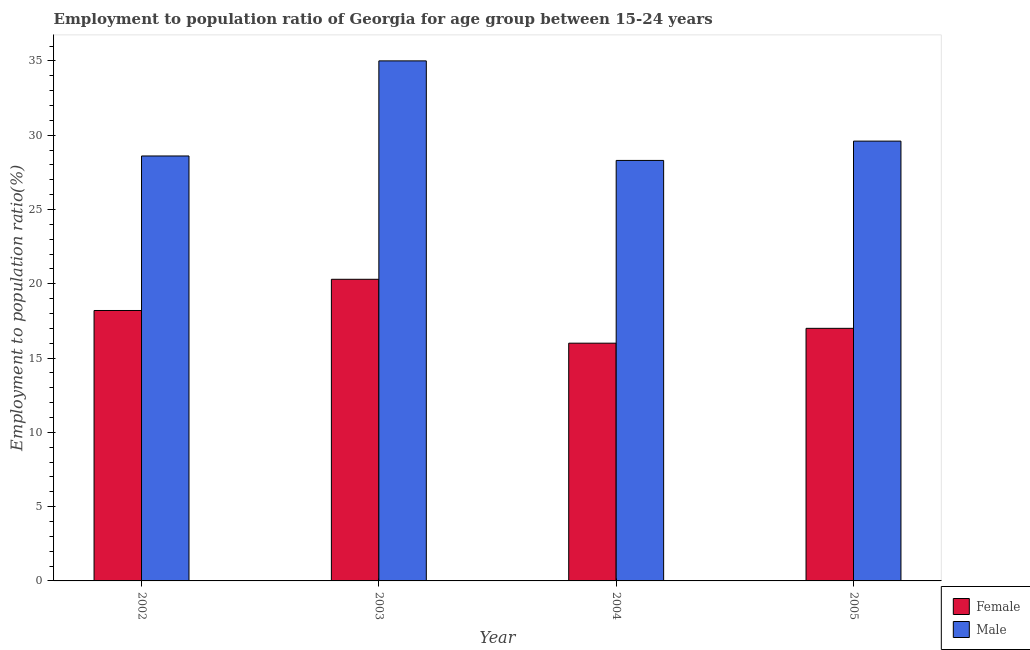How many groups of bars are there?
Provide a succinct answer. 4. Are the number of bars on each tick of the X-axis equal?
Offer a terse response. Yes. How many bars are there on the 4th tick from the right?
Your answer should be very brief. 2. What is the employment to population ratio(female) in 2004?
Keep it short and to the point. 16. Across all years, what is the maximum employment to population ratio(female)?
Give a very brief answer. 20.3. Across all years, what is the minimum employment to population ratio(male)?
Provide a succinct answer. 28.3. In which year was the employment to population ratio(male) minimum?
Provide a succinct answer. 2004. What is the total employment to population ratio(male) in the graph?
Provide a short and direct response. 121.5. What is the difference between the employment to population ratio(female) in 2002 and that in 2003?
Give a very brief answer. -2.1. What is the difference between the employment to population ratio(female) in 2005 and the employment to population ratio(male) in 2003?
Your response must be concise. -3.3. What is the average employment to population ratio(female) per year?
Provide a short and direct response. 17.88. In how many years, is the employment to population ratio(female) greater than 5 %?
Offer a terse response. 4. What is the ratio of the employment to population ratio(male) in 2004 to that in 2005?
Provide a short and direct response. 0.96. Is the employment to population ratio(male) in 2003 less than that in 2004?
Your response must be concise. No. Is the difference between the employment to population ratio(female) in 2004 and 2005 greater than the difference between the employment to population ratio(male) in 2004 and 2005?
Your answer should be very brief. No. What is the difference between the highest and the second highest employment to population ratio(female)?
Provide a short and direct response. 2.1. What is the difference between the highest and the lowest employment to population ratio(male)?
Keep it short and to the point. 6.7. How many bars are there?
Ensure brevity in your answer.  8. Are all the bars in the graph horizontal?
Your answer should be very brief. No. How many years are there in the graph?
Your response must be concise. 4. What is the difference between two consecutive major ticks on the Y-axis?
Provide a short and direct response. 5. Are the values on the major ticks of Y-axis written in scientific E-notation?
Keep it short and to the point. No. Where does the legend appear in the graph?
Make the answer very short. Bottom right. How are the legend labels stacked?
Ensure brevity in your answer.  Vertical. What is the title of the graph?
Keep it short and to the point. Employment to population ratio of Georgia for age group between 15-24 years. What is the Employment to population ratio(%) of Female in 2002?
Offer a very short reply. 18.2. What is the Employment to population ratio(%) of Male in 2002?
Offer a terse response. 28.6. What is the Employment to population ratio(%) in Female in 2003?
Offer a terse response. 20.3. What is the Employment to population ratio(%) in Male in 2003?
Make the answer very short. 35. What is the Employment to population ratio(%) of Female in 2004?
Your answer should be compact. 16. What is the Employment to population ratio(%) in Male in 2004?
Offer a terse response. 28.3. What is the Employment to population ratio(%) in Female in 2005?
Ensure brevity in your answer.  17. What is the Employment to population ratio(%) of Male in 2005?
Ensure brevity in your answer.  29.6. Across all years, what is the maximum Employment to population ratio(%) in Female?
Your answer should be compact. 20.3. Across all years, what is the minimum Employment to population ratio(%) in Male?
Keep it short and to the point. 28.3. What is the total Employment to population ratio(%) in Female in the graph?
Provide a succinct answer. 71.5. What is the total Employment to population ratio(%) of Male in the graph?
Provide a short and direct response. 121.5. What is the difference between the Employment to population ratio(%) of Male in 2002 and that in 2003?
Give a very brief answer. -6.4. What is the difference between the Employment to population ratio(%) in Male in 2002 and that in 2004?
Provide a short and direct response. 0.3. What is the difference between the Employment to population ratio(%) in Female in 2002 and that in 2005?
Keep it short and to the point. 1.2. What is the difference between the Employment to population ratio(%) in Female in 2003 and that in 2004?
Make the answer very short. 4.3. What is the difference between the Employment to population ratio(%) in Male in 2003 and that in 2004?
Provide a succinct answer. 6.7. What is the difference between the Employment to population ratio(%) of Male in 2003 and that in 2005?
Keep it short and to the point. 5.4. What is the difference between the Employment to population ratio(%) in Female in 2004 and that in 2005?
Ensure brevity in your answer.  -1. What is the difference between the Employment to population ratio(%) in Female in 2002 and the Employment to population ratio(%) in Male in 2003?
Make the answer very short. -16.8. What is the difference between the Employment to population ratio(%) in Female in 2002 and the Employment to population ratio(%) in Male in 2004?
Provide a short and direct response. -10.1. What is the average Employment to population ratio(%) in Female per year?
Provide a succinct answer. 17.88. What is the average Employment to population ratio(%) in Male per year?
Provide a short and direct response. 30.38. In the year 2002, what is the difference between the Employment to population ratio(%) in Female and Employment to population ratio(%) in Male?
Offer a terse response. -10.4. In the year 2003, what is the difference between the Employment to population ratio(%) in Female and Employment to population ratio(%) in Male?
Keep it short and to the point. -14.7. In the year 2004, what is the difference between the Employment to population ratio(%) of Female and Employment to population ratio(%) of Male?
Your response must be concise. -12.3. In the year 2005, what is the difference between the Employment to population ratio(%) of Female and Employment to population ratio(%) of Male?
Make the answer very short. -12.6. What is the ratio of the Employment to population ratio(%) in Female in 2002 to that in 2003?
Your response must be concise. 0.9. What is the ratio of the Employment to population ratio(%) of Male in 2002 to that in 2003?
Your answer should be very brief. 0.82. What is the ratio of the Employment to population ratio(%) of Female in 2002 to that in 2004?
Provide a short and direct response. 1.14. What is the ratio of the Employment to population ratio(%) in Male in 2002 to that in 2004?
Provide a short and direct response. 1.01. What is the ratio of the Employment to population ratio(%) of Female in 2002 to that in 2005?
Make the answer very short. 1.07. What is the ratio of the Employment to population ratio(%) of Male in 2002 to that in 2005?
Offer a very short reply. 0.97. What is the ratio of the Employment to population ratio(%) in Female in 2003 to that in 2004?
Make the answer very short. 1.27. What is the ratio of the Employment to population ratio(%) in Male in 2003 to that in 2004?
Your response must be concise. 1.24. What is the ratio of the Employment to population ratio(%) of Female in 2003 to that in 2005?
Offer a terse response. 1.19. What is the ratio of the Employment to population ratio(%) in Male in 2003 to that in 2005?
Offer a terse response. 1.18. What is the ratio of the Employment to population ratio(%) in Female in 2004 to that in 2005?
Offer a terse response. 0.94. What is the ratio of the Employment to population ratio(%) of Male in 2004 to that in 2005?
Provide a succinct answer. 0.96. What is the difference between the highest and the lowest Employment to population ratio(%) of Female?
Provide a succinct answer. 4.3. What is the difference between the highest and the lowest Employment to population ratio(%) of Male?
Your answer should be very brief. 6.7. 